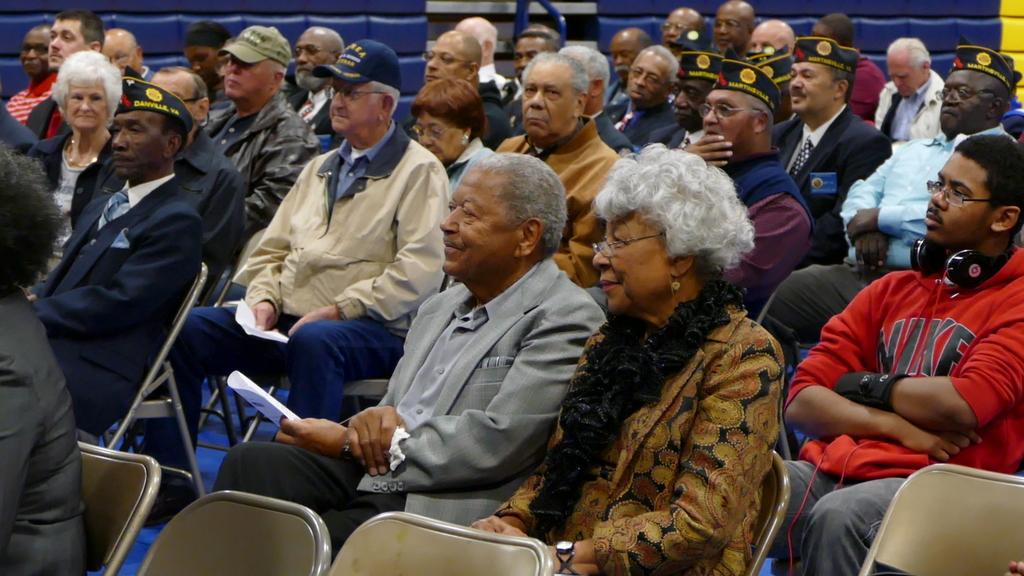How many people are in the image? There is a group of people in the image. What are some of the people doing in the image? Some of the people are sitting, and some are holding papers. What can be seen in the background of the image? There is a wall in the background of the image. What type of mine can be seen in the image? There is no mine present in the image. What color is the wire that the people are holding in the image? There is no wire present in the image; some people are holding papers. 